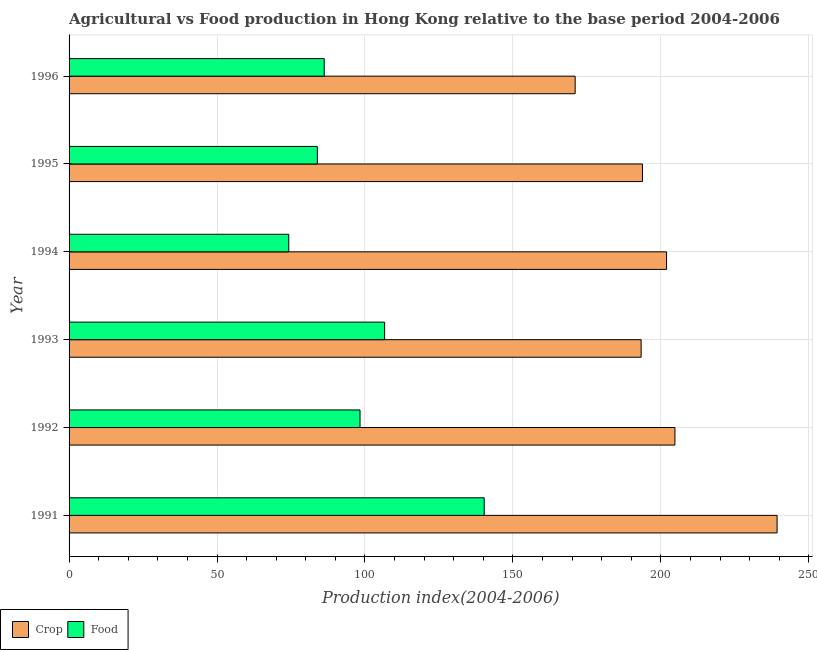How many different coloured bars are there?
Provide a succinct answer. 2. Are the number of bars on each tick of the Y-axis equal?
Offer a terse response. Yes. How many bars are there on the 4th tick from the top?
Your response must be concise. 2. In how many cases, is the number of bars for a given year not equal to the number of legend labels?
Give a very brief answer. 0. What is the crop production index in 1995?
Give a very brief answer. 193.77. Across all years, what is the maximum food production index?
Make the answer very short. 140.29. Across all years, what is the minimum food production index?
Your response must be concise. 74.24. In which year was the crop production index maximum?
Keep it short and to the point. 1991. What is the total food production index in the graph?
Your answer should be very brief. 589.62. What is the difference between the food production index in 1994 and that in 1996?
Give a very brief answer. -11.98. What is the difference between the crop production index in 1992 and the food production index in 1991?
Make the answer very short. 64.46. What is the average crop production index per year?
Your answer should be compact. 200.68. In the year 1991, what is the difference between the crop production index and food production index?
Ensure brevity in your answer.  98.98. In how many years, is the crop production index greater than 130 ?
Provide a succinct answer. 6. What is the ratio of the food production index in 1991 to that in 1996?
Your answer should be compact. 1.63. Is the crop production index in 1992 less than that in 1993?
Offer a very short reply. No. Is the difference between the food production index in 1992 and 1995 greater than the difference between the crop production index in 1992 and 1995?
Keep it short and to the point. Yes. What is the difference between the highest and the second highest food production index?
Make the answer very short. 33.65. What is the difference between the highest and the lowest crop production index?
Your answer should be very brief. 68.24. In how many years, is the food production index greater than the average food production index taken over all years?
Your answer should be compact. 3. Is the sum of the crop production index in 1991 and 1992 greater than the maximum food production index across all years?
Offer a very short reply. Yes. What does the 1st bar from the top in 1993 represents?
Your answer should be compact. Food. What does the 1st bar from the bottom in 1996 represents?
Your response must be concise. Crop. Does the graph contain grids?
Provide a short and direct response. Yes. How many legend labels are there?
Keep it short and to the point. 2. How are the legend labels stacked?
Provide a succinct answer. Horizontal. What is the title of the graph?
Offer a terse response. Agricultural vs Food production in Hong Kong relative to the base period 2004-2006. Does "Not attending school" appear as one of the legend labels in the graph?
Offer a terse response. No. What is the label or title of the X-axis?
Your answer should be compact. Production index(2004-2006). What is the Production index(2004-2006) of Crop in 1991?
Provide a short and direct response. 239.27. What is the Production index(2004-2006) in Food in 1991?
Your answer should be very brief. 140.29. What is the Production index(2004-2006) of Crop in 1992?
Your answer should be compact. 204.75. What is the Production index(2004-2006) of Food in 1992?
Ensure brevity in your answer.  98.33. What is the Production index(2004-2006) of Crop in 1993?
Provide a short and direct response. 193.32. What is the Production index(2004-2006) of Food in 1993?
Your response must be concise. 106.64. What is the Production index(2004-2006) of Crop in 1994?
Your response must be concise. 201.92. What is the Production index(2004-2006) in Food in 1994?
Provide a succinct answer. 74.24. What is the Production index(2004-2006) in Crop in 1995?
Give a very brief answer. 193.77. What is the Production index(2004-2006) in Food in 1995?
Keep it short and to the point. 83.9. What is the Production index(2004-2006) in Crop in 1996?
Give a very brief answer. 171.03. What is the Production index(2004-2006) of Food in 1996?
Your answer should be very brief. 86.22. Across all years, what is the maximum Production index(2004-2006) of Crop?
Your answer should be compact. 239.27. Across all years, what is the maximum Production index(2004-2006) of Food?
Provide a short and direct response. 140.29. Across all years, what is the minimum Production index(2004-2006) in Crop?
Keep it short and to the point. 171.03. Across all years, what is the minimum Production index(2004-2006) in Food?
Your answer should be very brief. 74.24. What is the total Production index(2004-2006) of Crop in the graph?
Give a very brief answer. 1204.06. What is the total Production index(2004-2006) of Food in the graph?
Provide a short and direct response. 589.62. What is the difference between the Production index(2004-2006) of Crop in 1991 and that in 1992?
Your answer should be compact. 34.52. What is the difference between the Production index(2004-2006) in Food in 1991 and that in 1992?
Provide a short and direct response. 41.96. What is the difference between the Production index(2004-2006) in Crop in 1991 and that in 1993?
Your answer should be very brief. 45.95. What is the difference between the Production index(2004-2006) in Food in 1991 and that in 1993?
Make the answer very short. 33.65. What is the difference between the Production index(2004-2006) of Crop in 1991 and that in 1994?
Make the answer very short. 37.35. What is the difference between the Production index(2004-2006) in Food in 1991 and that in 1994?
Offer a very short reply. 66.05. What is the difference between the Production index(2004-2006) in Crop in 1991 and that in 1995?
Your answer should be very brief. 45.5. What is the difference between the Production index(2004-2006) of Food in 1991 and that in 1995?
Offer a terse response. 56.39. What is the difference between the Production index(2004-2006) in Crop in 1991 and that in 1996?
Provide a short and direct response. 68.24. What is the difference between the Production index(2004-2006) in Food in 1991 and that in 1996?
Keep it short and to the point. 54.07. What is the difference between the Production index(2004-2006) in Crop in 1992 and that in 1993?
Ensure brevity in your answer.  11.43. What is the difference between the Production index(2004-2006) of Food in 1992 and that in 1993?
Your response must be concise. -8.31. What is the difference between the Production index(2004-2006) in Crop in 1992 and that in 1994?
Your answer should be compact. 2.83. What is the difference between the Production index(2004-2006) of Food in 1992 and that in 1994?
Offer a very short reply. 24.09. What is the difference between the Production index(2004-2006) in Crop in 1992 and that in 1995?
Your answer should be compact. 10.98. What is the difference between the Production index(2004-2006) of Food in 1992 and that in 1995?
Offer a very short reply. 14.43. What is the difference between the Production index(2004-2006) of Crop in 1992 and that in 1996?
Your answer should be very brief. 33.72. What is the difference between the Production index(2004-2006) in Food in 1992 and that in 1996?
Your answer should be very brief. 12.11. What is the difference between the Production index(2004-2006) in Crop in 1993 and that in 1994?
Offer a terse response. -8.6. What is the difference between the Production index(2004-2006) in Food in 1993 and that in 1994?
Provide a succinct answer. 32.4. What is the difference between the Production index(2004-2006) of Crop in 1993 and that in 1995?
Your response must be concise. -0.45. What is the difference between the Production index(2004-2006) of Food in 1993 and that in 1995?
Your answer should be compact. 22.74. What is the difference between the Production index(2004-2006) in Crop in 1993 and that in 1996?
Ensure brevity in your answer.  22.29. What is the difference between the Production index(2004-2006) of Food in 1993 and that in 1996?
Make the answer very short. 20.42. What is the difference between the Production index(2004-2006) in Crop in 1994 and that in 1995?
Your answer should be very brief. 8.15. What is the difference between the Production index(2004-2006) of Food in 1994 and that in 1995?
Keep it short and to the point. -9.66. What is the difference between the Production index(2004-2006) in Crop in 1994 and that in 1996?
Give a very brief answer. 30.89. What is the difference between the Production index(2004-2006) of Food in 1994 and that in 1996?
Give a very brief answer. -11.98. What is the difference between the Production index(2004-2006) of Crop in 1995 and that in 1996?
Your answer should be compact. 22.74. What is the difference between the Production index(2004-2006) in Food in 1995 and that in 1996?
Provide a succinct answer. -2.32. What is the difference between the Production index(2004-2006) of Crop in 1991 and the Production index(2004-2006) of Food in 1992?
Provide a succinct answer. 140.94. What is the difference between the Production index(2004-2006) in Crop in 1991 and the Production index(2004-2006) in Food in 1993?
Provide a short and direct response. 132.63. What is the difference between the Production index(2004-2006) in Crop in 1991 and the Production index(2004-2006) in Food in 1994?
Provide a succinct answer. 165.03. What is the difference between the Production index(2004-2006) of Crop in 1991 and the Production index(2004-2006) of Food in 1995?
Ensure brevity in your answer.  155.37. What is the difference between the Production index(2004-2006) in Crop in 1991 and the Production index(2004-2006) in Food in 1996?
Your response must be concise. 153.05. What is the difference between the Production index(2004-2006) of Crop in 1992 and the Production index(2004-2006) of Food in 1993?
Ensure brevity in your answer.  98.11. What is the difference between the Production index(2004-2006) of Crop in 1992 and the Production index(2004-2006) of Food in 1994?
Provide a short and direct response. 130.51. What is the difference between the Production index(2004-2006) in Crop in 1992 and the Production index(2004-2006) in Food in 1995?
Your response must be concise. 120.85. What is the difference between the Production index(2004-2006) of Crop in 1992 and the Production index(2004-2006) of Food in 1996?
Make the answer very short. 118.53. What is the difference between the Production index(2004-2006) in Crop in 1993 and the Production index(2004-2006) in Food in 1994?
Your answer should be very brief. 119.08. What is the difference between the Production index(2004-2006) in Crop in 1993 and the Production index(2004-2006) in Food in 1995?
Offer a terse response. 109.42. What is the difference between the Production index(2004-2006) in Crop in 1993 and the Production index(2004-2006) in Food in 1996?
Your response must be concise. 107.1. What is the difference between the Production index(2004-2006) in Crop in 1994 and the Production index(2004-2006) in Food in 1995?
Offer a very short reply. 118.02. What is the difference between the Production index(2004-2006) of Crop in 1994 and the Production index(2004-2006) of Food in 1996?
Provide a succinct answer. 115.7. What is the difference between the Production index(2004-2006) in Crop in 1995 and the Production index(2004-2006) in Food in 1996?
Offer a terse response. 107.55. What is the average Production index(2004-2006) of Crop per year?
Provide a short and direct response. 200.68. What is the average Production index(2004-2006) of Food per year?
Your response must be concise. 98.27. In the year 1991, what is the difference between the Production index(2004-2006) in Crop and Production index(2004-2006) in Food?
Provide a succinct answer. 98.98. In the year 1992, what is the difference between the Production index(2004-2006) of Crop and Production index(2004-2006) of Food?
Your response must be concise. 106.42. In the year 1993, what is the difference between the Production index(2004-2006) in Crop and Production index(2004-2006) in Food?
Provide a short and direct response. 86.68. In the year 1994, what is the difference between the Production index(2004-2006) in Crop and Production index(2004-2006) in Food?
Offer a terse response. 127.68. In the year 1995, what is the difference between the Production index(2004-2006) of Crop and Production index(2004-2006) of Food?
Provide a succinct answer. 109.87. In the year 1996, what is the difference between the Production index(2004-2006) in Crop and Production index(2004-2006) in Food?
Offer a very short reply. 84.81. What is the ratio of the Production index(2004-2006) of Crop in 1991 to that in 1992?
Your answer should be very brief. 1.17. What is the ratio of the Production index(2004-2006) of Food in 1991 to that in 1992?
Offer a terse response. 1.43. What is the ratio of the Production index(2004-2006) of Crop in 1991 to that in 1993?
Offer a very short reply. 1.24. What is the ratio of the Production index(2004-2006) in Food in 1991 to that in 1993?
Provide a short and direct response. 1.32. What is the ratio of the Production index(2004-2006) in Crop in 1991 to that in 1994?
Provide a short and direct response. 1.19. What is the ratio of the Production index(2004-2006) in Food in 1991 to that in 1994?
Your answer should be very brief. 1.89. What is the ratio of the Production index(2004-2006) of Crop in 1991 to that in 1995?
Ensure brevity in your answer.  1.23. What is the ratio of the Production index(2004-2006) of Food in 1991 to that in 1995?
Keep it short and to the point. 1.67. What is the ratio of the Production index(2004-2006) in Crop in 1991 to that in 1996?
Your answer should be compact. 1.4. What is the ratio of the Production index(2004-2006) in Food in 1991 to that in 1996?
Offer a very short reply. 1.63. What is the ratio of the Production index(2004-2006) in Crop in 1992 to that in 1993?
Provide a short and direct response. 1.06. What is the ratio of the Production index(2004-2006) of Food in 1992 to that in 1993?
Offer a very short reply. 0.92. What is the ratio of the Production index(2004-2006) of Crop in 1992 to that in 1994?
Offer a terse response. 1.01. What is the ratio of the Production index(2004-2006) of Food in 1992 to that in 1994?
Provide a succinct answer. 1.32. What is the ratio of the Production index(2004-2006) in Crop in 1992 to that in 1995?
Your answer should be compact. 1.06. What is the ratio of the Production index(2004-2006) of Food in 1992 to that in 1995?
Provide a succinct answer. 1.17. What is the ratio of the Production index(2004-2006) in Crop in 1992 to that in 1996?
Your answer should be compact. 1.2. What is the ratio of the Production index(2004-2006) in Food in 1992 to that in 1996?
Your answer should be compact. 1.14. What is the ratio of the Production index(2004-2006) of Crop in 1993 to that in 1994?
Give a very brief answer. 0.96. What is the ratio of the Production index(2004-2006) in Food in 1993 to that in 1994?
Keep it short and to the point. 1.44. What is the ratio of the Production index(2004-2006) of Crop in 1993 to that in 1995?
Keep it short and to the point. 1. What is the ratio of the Production index(2004-2006) in Food in 1993 to that in 1995?
Make the answer very short. 1.27. What is the ratio of the Production index(2004-2006) in Crop in 1993 to that in 1996?
Provide a short and direct response. 1.13. What is the ratio of the Production index(2004-2006) in Food in 1993 to that in 1996?
Provide a succinct answer. 1.24. What is the ratio of the Production index(2004-2006) of Crop in 1994 to that in 1995?
Keep it short and to the point. 1.04. What is the ratio of the Production index(2004-2006) of Food in 1994 to that in 1995?
Ensure brevity in your answer.  0.88. What is the ratio of the Production index(2004-2006) of Crop in 1994 to that in 1996?
Provide a succinct answer. 1.18. What is the ratio of the Production index(2004-2006) in Food in 1994 to that in 1996?
Offer a terse response. 0.86. What is the ratio of the Production index(2004-2006) in Crop in 1995 to that in 1996?
Keep it short and to the point. 1.13. What is the ratio of the Production index(2004-2006) in Food in 1995 to that in 1996?
Your response must be concise. 0.97. What is the difference between the highest and the second highest Production index(2004-2006) in Crop?
Offer a very short reply. 34.52. What is the difference between the highest and the second highest Production index(2004-2006) of Food?
Your answer should be compact. 33.65. What is the difference between the highest and the lowest Production index(2004-2006) of Crop?
Provide a succinct answer. 68.24. What is the difference between the highest and the lowest Production index(2004-2006) of Food?
Your answer should be compact. 66.05. 